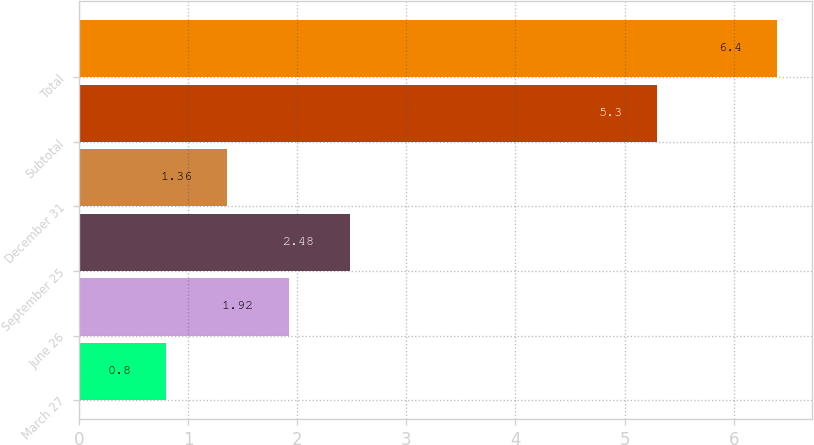Convert chart to OTSL. <chart><loc_0><loc_0><loc_500><loc_500><bar_chart><fcel>March 27<fcel>June 26<fcel>September 25<fcel>December 31<fcel>Subtotal<fcel>Total<nl><fcel>0.8<fcel>1.92<fcel>2.48<fcel>1.36<fcel>5.3<fcel>6.4<nl></chart> 